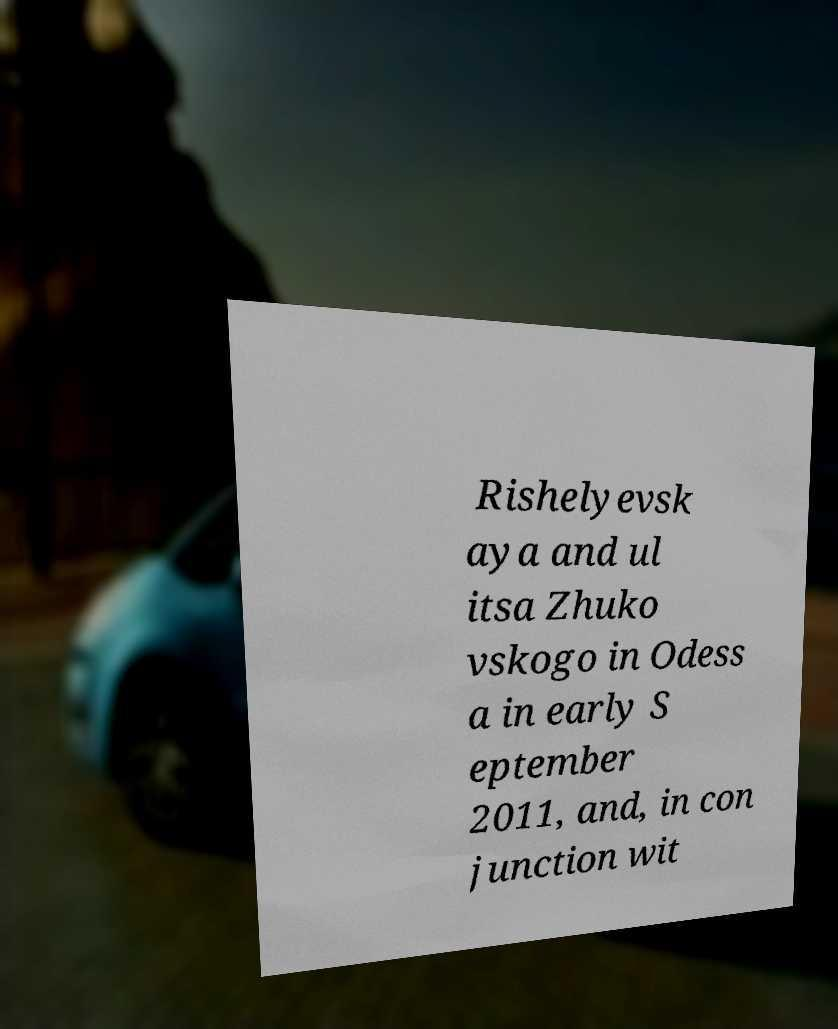Could you assist in decoding the text presented in this image and type it out clearly? Rishelyevsk aya and ul itsa Zhuko vskogo in Odess a in early S eptember 2011, and, in con junction wit 